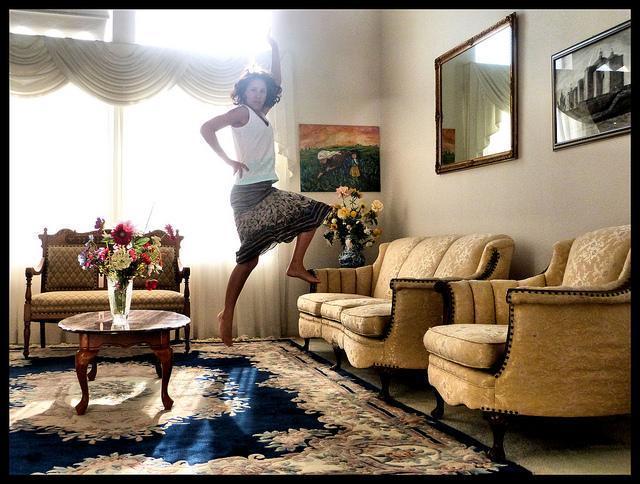How many couches are in the photo?
Give a very brief answer. 2. How many potted plants are there?
Give a very brief answer. 2. How many chairs are in the photo?
Give a very brief answer. 2. How many bicycles are visible in this picture?
Give a very brief answer. 0. 